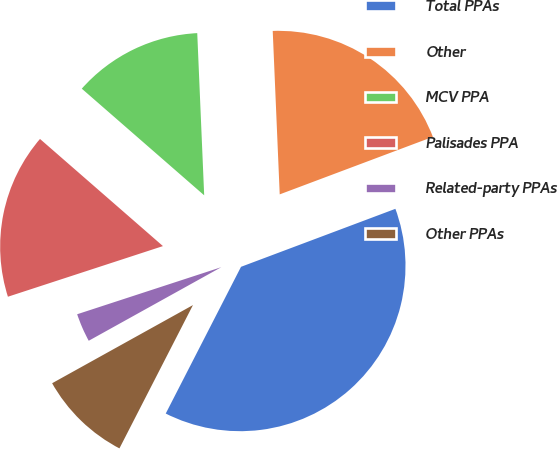<chart> <loc_0><loc_0><loc_500><loc_500><pie_chart><fcel>Total PPAs<fcel>Other<fcel>MCV PPA<fcel>Palisades PPA<fcel>Related-party PPAs<fcel>Other PPAs<nl><fcel>38.26%<fcel>19.96%<fcel>12.91%<fcel>16.43%<fcel>3.04%<fcel>9.39%<nl></chart> 